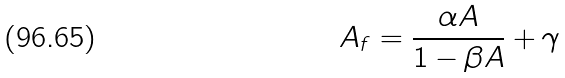<formula> <loc_0><loc_0><loc_500><loc_500>A _ { f } = \frac { \alpha A } { 1 - \beta A } + \gamma</formula> 